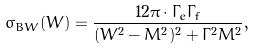<formula> <loc_0><loc_0><loc_500><loc_500>\sigma _ { B W } ( W ) = \frac { 1 2 \pi \cdot \Gamma _ { e } \Gamma _ { f } } { ( W ^ { 2 } - M ^ { 2 } ) ^ { 2 } + \Gamma ^ { 2 } M ^ { 2 } } ,</formula> 